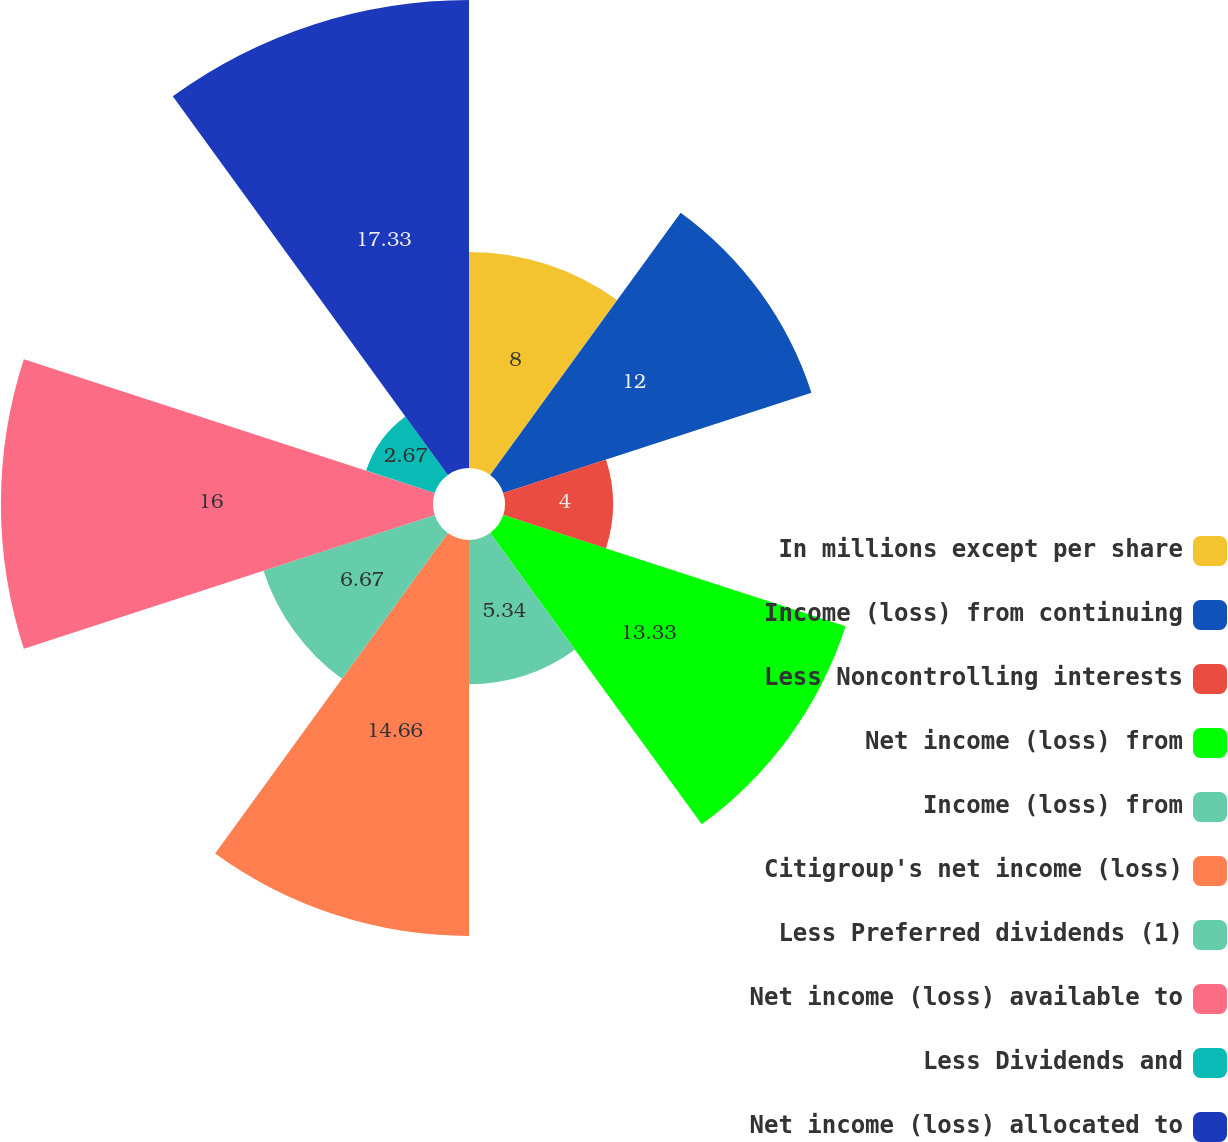Convert chart to OTSL. <chart><loc_0><loc_0><loc_500><loc_500><pie_chart><fcel>In millions except per share<fcel>Income (loss) from continuing<fcel>Less Noncontrolling interests<fcel>Net income (loss) from<fcel>Income (loss) from<fcel>Citigroup's net income (loss)<fcel>Less Preferred dividends (1)<fcel>Net income (loss) available to<fcel>Less Dividends and<fcel>Net income (loss) allocated to<nl><fcel>8.0%<fcel>12.0%<fcel>4.0%<fcel>13.33%<fcel>5.34%<fcel>14.66%<fcel>6.67%<fcel>16.0%<fcel>2.67%<fcel>17.33%<nl></chart> 